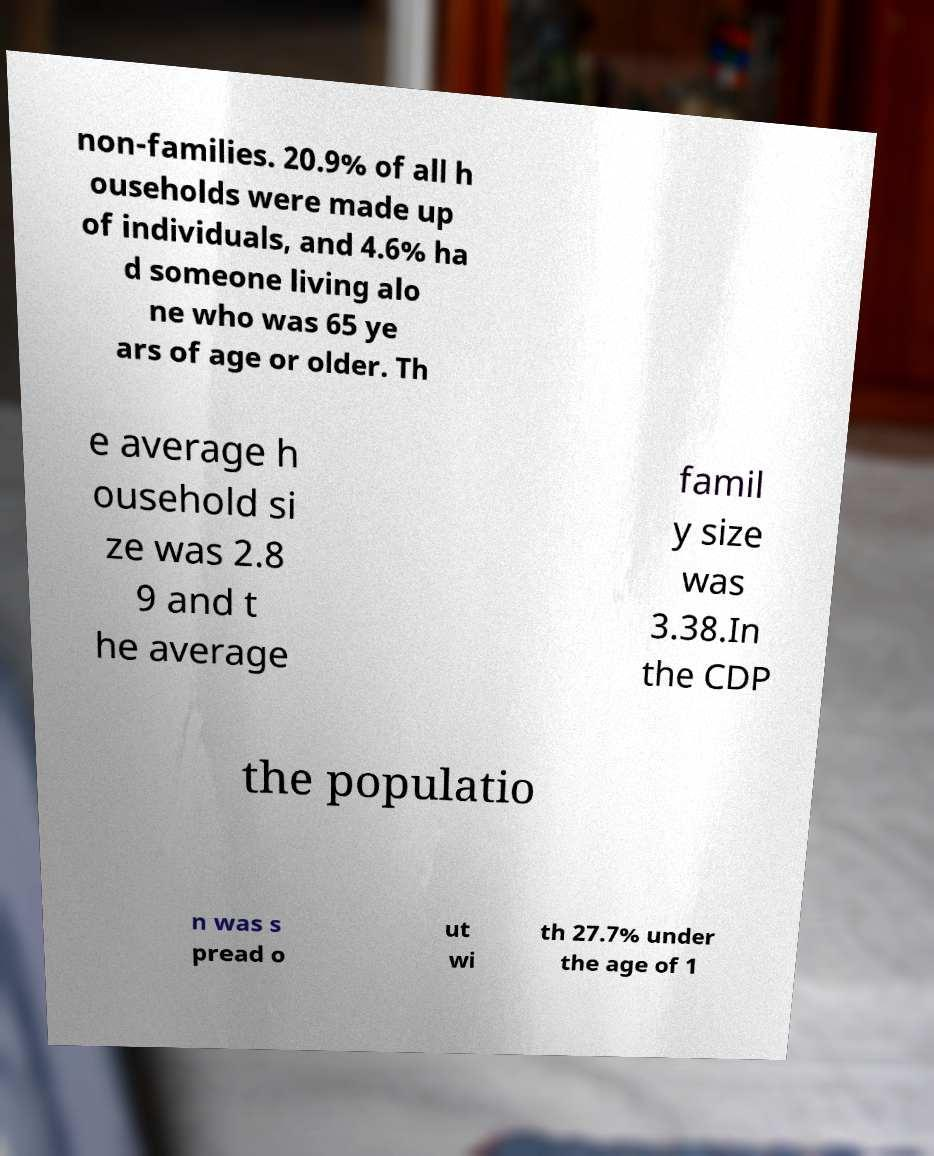Can you read and provide the text displayed in the image?This photo seems to have some interesting text. Can you extract and type it out for me? non-families. 20.9% of all h ouseholds were made up of individuals, and 4.6% ha d someone living alo ne who was 65 ye ars of age or older. Th e average h ousehold si ze was 2.8 9 and t he average famil y size was 3.38.In the CDP the populatio n was s pread o ut wi th 27.7% under the age of 1 